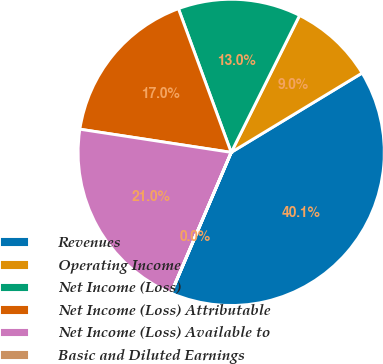Convert chart. <chart><loc_0><loc_0><loc_500><loc_500><pie_chart><fcel>Revenues<fcel>Operating Income<fcel>Net Income (Loss)<fcel>Net Income (Loss) Attributable<fcel>Net Income (Loss) Available to<fcel>Basic and Diluted Earnings<nl><fcel>40.09%<fcel>8.96%<fcel>12.97%<fcel>16.98%<fcel>20.99%<fcel>0.01%<nl></chart> 